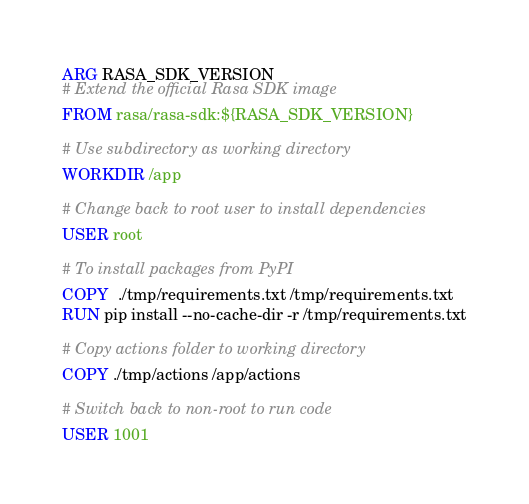<code> <loc_0><loc_0><loc_500><loc_500><_Dockerfile_>ARG RASA_SDK_VERSION
# Extend the official Rasa SDK image
FROM rasa/rasa-sdk:${RASA_SDK_VERSION}

# Use subdirectory as working directory
WORKDIR /app

# Change back to root user to install dependencies
USER root

# To install packages from PyPI
COPY  ./tmp/requirements.txt /tmp/requirements.txt
RUN pip install --no-cache-dir -r /tmp/requirements.txt

# Copy actions folder to working directory
COPY ./tmp/actions /app/actions

# Switch back to non-root to run code
USER 1001
</code> 